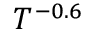Convert formula to latex. <formula><loc_0><loc_0><loc_500><loc_500>T ^ { - 0 . 6 }</formula> 